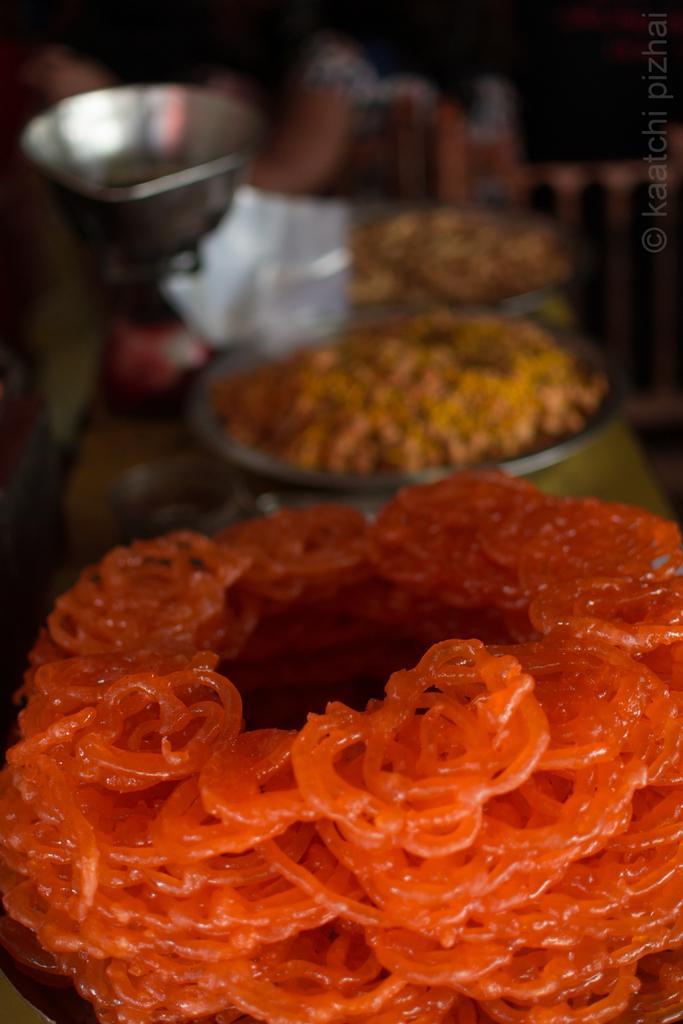Could you give a brief overview of what you see in this image? At the bottom of this image, there are orange color, sweets arranged on a surface. In the background, there are other food items arranged, there are a vessel and other objects. And the background is blurred. 